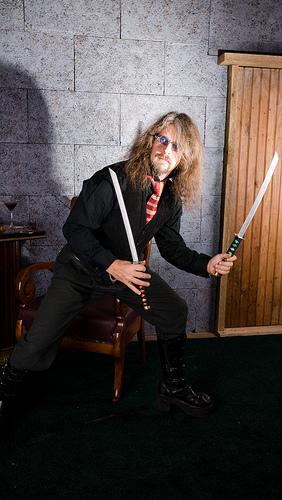How many swords does the man have?
Give a very brief answer. 2. What color is the chair?
Concise answer only. Brown. What color is the man's tie?
Give a very brief answer. Red and white. 